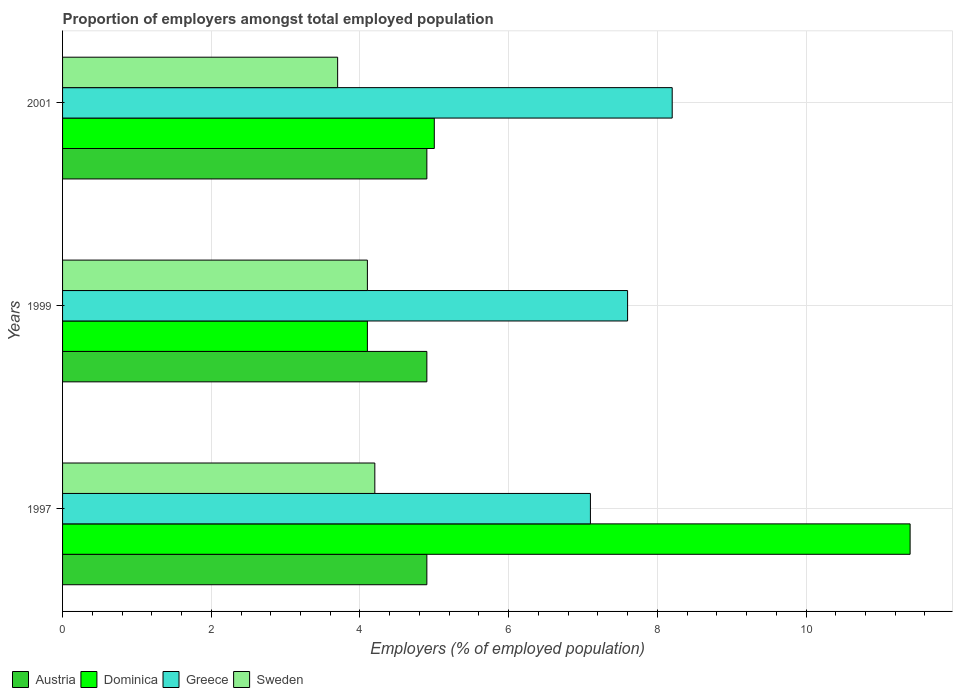How many different coloured bars are there?
Provide a succinct answer. 4. Are the number of bars per tick equal to the number of legend labels?
Make the answer very short. Yes. How many bars are there on the 2nd tick from the top?
Offer a terse response. 4. What is the proportion of employers in Dominica in 2001?
Offer a terse response. 5. Across all years, what is the maximum proportion of employers in Sweden?
Your response must be concise. 4.2. Across all years, what is the minimum proportion of employers in Dominica?
Your response must be concise. 4.1. In which year was the proportion of employers in Austria maximum?
Offer a terse response. 1997. What is the total proportion of employers in Dominica in the graph?
Provide a succinct answer. 20.5. What is the difference between the proportion of employers in Greece in 1999 and that in 2001?
Give a very brief answer. -0.6. What is the difference between the proportion of employers in Sweden in 1999 and the proportion of employers in Austria in 2001?
Your answer should be very brief. -0.8. What is the average proportion of employers in Sweden per year?
Offer a terse response. 4. In how many years, is the proportion of employers in Dominica greater than 4.8 %?
Make the answer very short. 2. What is the ratio of the proportion of employers in Greece in 1997 to that in 2001?
Provide a short and direct response. 0.87. Is the proportion of employers in Dominica in 1997 less than that in 1999?
Provide a short and direct response. No. Is the difference between the proportion of employers in Dominica in 1997 and 2001 greater than the difference between the proportion of employers in Sweden in 1997 and 2001?
Make the answer very short. Yes. What is the difference between the highest and the second highest proportion of employers in Dominica?
Ensure brevity in your answer.  6.4. What is the difference between the highest and the lowest proportion of employers in Sweden?
Offer a terse response. 0.5. In how many years, is the proportion of employers in Dominica greater than the average proportion of employers in Dominica taken over all years?
Your response must be concise. 1. Is it the case that in every year, the sum of the proportion of employers in Dominica and proportion of employers in Sweden is greater than the sum of proportion of employers in Austria and proportion of employers in Greece?
Offer a very short reply. Yes. What does the 3rd bar from the top in 1997 represents?
Your answer should be compact. Dominica. What does the 2nd bar from the bottom in 1997 represents?
Offer a terse response. Dominica. Is it the case that in every year, the sum of the proportion of employers in Dominica and proportion of employers in Sweden is greater than the proportion of employers in Austria?
Your response must be concise. Yes. Are all the bars in the graph horizontal?
Offer a terse response. Yes. What is the difference between two consecutive major ticks on the X-axis?
Your answer should be very brief. 2. Are the values on the major ticks of X-axis written in scientific E-notation?
Give a very brief answer. No. Does the graph contain grids?
Ensure brevity in your answer.  Yes. How many legend labels are there?
Offer a very short reply. 4. How are the legend labels stacked?
Your answer should be compact. Horizontal. What is the title of the graph?
Offer a terse response. Proportion of employers amongst total employed population. Does "Honduras" appear as one of the legend labels in the graph?
Your answer should be very brief. No. What is the label or title of the X-axis?
Your answer should be compact. Employers (% of employed population). What is the label or title of the Y-axis?
Provide a short and direct response. Years. What is the Employers (% of employed population) of Austria in 1997?
Provide a short and direct response. 4.9. What is the Employers (% of employed population) of Dominica in 1997?
Ensure brevity in your answer.  11.4. What is the Employers (% of employed population) of Greece in 1997?
Ensure brevity in your answer.  7.1. What is the Employers (% of employed population) of Sweden in 1997?
Offer a terse response. 4.2. What is the Employers (% of employed population) of Austria in 1999?
Provide a short and direct response. 4.9. What is the Employers (% of employed population) of Dominica in 1999?
Make the answer very short. 4.1. What is the Employers (% of employed population) in Greece in 1999?
Offer a very short reply. 7.6. What is the Employers (% of employed population) in Sweden in 1999?
Your response must be concise. 4.1. What is the Employers (% of employed population) in Austria in 2001?
Make the answer very short. 4.9. What is the Employers (% of employed population) in Greece in 2001?
Provide a short and direct response. 8.2. What is the Employers (% of employed population) in Sweden in 2001?
Offer a terse response. 3.7. Across all years, what is the maximum Employers (% of employed population) of Austria?
Give a very brief answer. 4.9. Across all years, what is the maximum Employers (% of employed population) in Dominica?
Offer a very short reply. 11.4. Across all years, what is the maximum Employers (% of employed population) in Greece?
Offer a terse response. 8.2. Across all years, what is the maximum Employers (% of employed population) of Sweden?
Your answer should be compact. 4.2. Across all years, what is the minimum Employers (% of employed population) in Austria?
Ensure brevity in your answer.  4.9. Across all years, what is the minimum Employers (% of employed population) of Dominica?
Make the answer very short. 4.1. Across all years, what is the minimum Employers (% of employed population) in Greece?
Give a very brief answer. 7.1. Across all years, what is the minimum Employers (% of employed population) of Sweden?
Make the answer very short. 3.7. What is the total Employers (% of employed population) of Austria in the graph?
Give a very brief answer. 14.7. What is the total Employers (% of employed population) of Dominica in the graph?
Provide a short and direct response. 20.5. What is the total Employers (% of employed population) in Greece in the graph?
Ensure brevity in your answer.  22.9. What is the total Employers (% of employed population) in Sweden in the graph?
Your answer should be very brief. 12. What is the difference between the Employers (% of employed population) in Austria in 1997 and that in 1999?
Offer a very short reply. 0. What is the difference between the Employers (% of employed population) of Sweden in 1997 and that in 1999?
Make the answer very short. 0.1. What is the difference between the Employers (% of employed population) in Austria in 1997 and that in 2001?
Your answer should be very brief. 0. What is the difference between the Employers (% of employed population) of Greece in 1997 and that in 2001?
Make the answer very short. -1.1. What is the difference between the Employers (% of employed population) of Sweden in 1997 and that in 2001?
Give a very brief answer. 0.5. What is the difference between the Employers (% of employed population) in Austria in 1999 and that in 2001?
Your answer should be compact. 0. What is the difference between the Employers (% of employed population) of Dominica in 1999 and that in 2001?
Make the answer very short. -0.9. What is the difference between the Employers (% of employed population) of Sweden in 1999 and that in 2001?
Your answer should be very brief. 0.4. What is the difference between the Employers (% of employed population) of Austria in 1997 and the Employers (% of employed population) of Greece in 1999?
Offer a very short reply. -2.7. What is the difference between the Employers (% of employed population) in Austria in 1997 and the Employers (% of employed population) in Dominica in 2001?
Make the answer very short. -0.1. What is the difference between the Employers (% of employed population) of Dominica in 1999 and the Employers (% of employed population) of Greece in 2001?
Your answer should be compact. -4.1. What is the difference between the Employers (% of employed population) of Dominica in 1999 and the Employers (% of employed population) of Sweden in 2001?
Provide a short and direct response. 0.4. What is the difference between the Employers (% of employed population) in Greece in 1999 and the Employers (% of employed population) in Sweden in 2001?
Provide a succinct answer. 3.9. What is the average Employers (% of employed population) in Dominica per year?
Your response must be concise. 6.83. What is the average Employers (% of employed population) in Greece per year?
Provide a short and direct response. 7.63. In the year 1997, what is the difference between the Employers (% of employed population) in Austria and Employers (% of employed population) in Dominica?
Provide a short and direct response. -6.5. In the year 1997, what is the difference between the Employers (% of employed population) of Austria and Employers (% of employed population) of Sweden?
Offer a very short reply. 0.7. In the year 1997, what is the difference between the Employers (% of employed population) of Dominica and Employers (% of employed population) of Greece?
Your response must be concise. 4.3. In the year 1997, what is the difference between the Employers (% of employed population) in Dominica and Employers (% of employed population) in Sweden?
Provide a succinct answer. 7.2. In the year 1997, what is the difference between the Employers (% of employed population) of Greece and Employers (% of employed population) of Sweden?
Give a very brief answer. 2.9. In the year 1999, what is the difference between the Employers (% of employed population) in Austria and Employers (% of employed population) in Dominica?
Your answer should be very brief. 0.8. In the year 1999, what is the difference between the Employers (% of employed population) of Austria and Employers (% of employed population) of Greece?
Offer a terse response. -2.7. In the year 1999, what is the difference between the Employers (% of employed population) of Austria and Employers (% of employed population) of Sweden?
Keep it short and to the point. 0.8. In the year 1999, what is the difference between the Employers (% of employed population) of Dominica and Employers (% of employed population) of Greece?
Offer a terse response. -3.5. In the year 1999, what is the difference between the Employers (% of employed population) in Dominica and Employers (% of employed population) in Sweden?
Provide a short and direct response. 0. In the year 1999, what is the difference between the Employers (% of employed population) of Greece and Employers (% of employed population) of Sweden?
Offer a very short reply. 3.5. In the year 2001, what is the difference between the Employers (% of employed population) of Austria and Employers (% of employed population) of Dominica?
Offer a very short reply. -0.1. In the year 2001, what is the difference between the Employers (% of employed population) in Austria and Employers (% of employed population) in Greece?
Your answer should be very brief. -3.3. In the year 2001, what is the difference between the Employers (% of employed population) in Austria and Employers (% of employed population) in Sweden?
Offer a terse response. 1.2. In the year 2001, what is the difference between the Employers (% of employed population) of Dominica and Employers (% of employed population) of Greece?
Give a very brief answer. -3.2. In the year 2001, what is the difference between the Employers (% of employed population) in Dominica and Employers (% of employed population) in Sweden?
Give a very brief answer. 1.3. What is the ratio of the Employers (% of employed population) in Austria in 1997 to that in 1999?
Make the answer very short. 1. What is the ratio of the Employers (% of employed population) of Dominica in 1997 to that in 1999?
Give a very brief answer. 2.78. What is the ratio of the Employers (% of employed population) in Greece in 1997 to that in 1999?
Provide a succinct answer. 0.93. What is the ratio of the Employers (% of employed population) in Sweden in 1997 to that in 1999?
Keep it short and to the point. 1.02. What is the ratio of the Employers (% of employed population) in Dominica in 1997 to that in 2001?
Provide a short and direct response. 2.28. What is the ratio of the Employers (% of employed population) in Greece in 1997 to that in 2001?
Your answer should be very brief. 0.87. What is the ratio of the Employers (% of employed population) in Sweden in 1997 to that in 2001?
Ensure brevity in your answer.  1.14. What is the ratio of the Employers (% of employed population) in Dominica in 1999 to that in 2001?
Give a very brief answer. 0.82. What is the ratio of the Employers (% of employed population) of Greece in 1999 to that in 2001?
Ensure brevity in your answer.  0.93. What is the ratio of the Employers (% of employed population) in Sweden in 1999 to that in 2001?
Give a very brief answer. 1.11. What is the difference between the highest and the second highest Employers (% of employed population) in Austria?
Offer a terse response. 0. What is the difference between the highest and the lowest Employers (% of employed population) of Dominica?
Give a very brief answer. 7.3. 